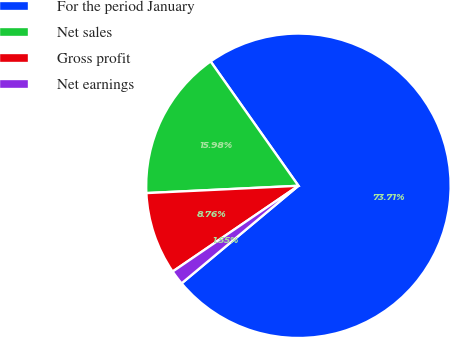Convert chart to OTSL. <chart><loc_0><loc_0><loc_500><loc_500><pie_chart><fcel>For the period January<fcel>Net sales<fcel>Gross profit<fcel>Net earnings<nl><fcel>73.71%<fcel>15.98%<fcel>8.76%<fcel>1.55%<nl></chart> 